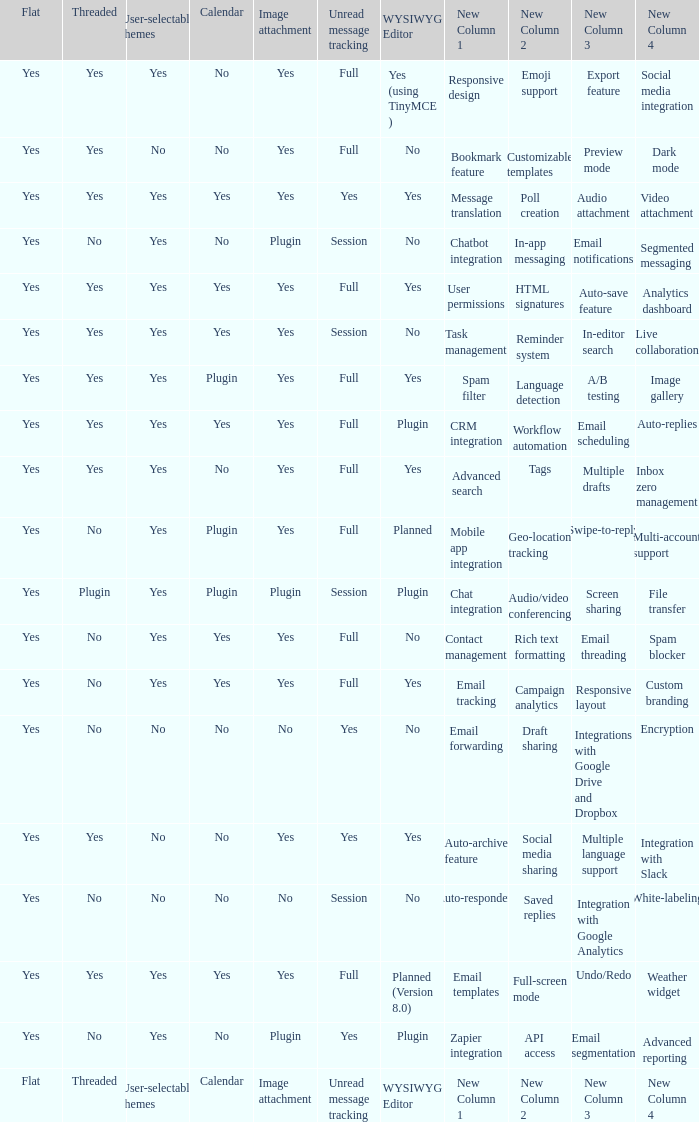Which Calendar has a WYSIWYG Editor of no, and an Unread message tracking of session, and an Image attachment of no? No. Could you help me parse every detail presented in this table? {'header': ['Flat', 'Threaded', 'User-selectable themes', 'Calendar', 'Image attachment', 'Unread message tracking', 'WYSIWYG Editor', 'New Column 1', 'New Column 2', 'New Column 3', 'New Column 4'], 'rows': [['Yes', 'Yes', 'Yes', 'No', 'Yes', 'Full', 'Yes (using TinyMCE )', 'Responsive design', 'Emoji support', 'Export feature', 'Social media integration'], ['Yes', 'Yes', 'No', 'No', 'Yes', 'Full', 'No', 'Bookmark feature', 'Customizable templates', 'Preview mode', 'Dark mode '], ['Yes', 'Yes', 'Yes', 'Yes', 'Yes', 'Yes', 'Yes', 'Message translation', 'Poll creation', 'Audio attachment', 'Video attachment '], ['Yes', 'No', 'Yes', 'No', 'Plugin', 'Session', 'No', 'Chatbot integration', 'In-app messaging', 'Email notifications', 'Segmented messaging'], ['Yes', 'Yes', 'Yes', 'Yes', 'Yes', 'Full', 'Yes', 'User permissions', 'HTML signatures', 'Auto-save feature', 'Analytics dashboard'], ['Yes', 'Yes', 'Yes', 'Yes', 'Yes', 'Session', 'No', 'Task management', 'Reminder system', 'In-editor search', 'Live collaboration'], ['Yes', 'Yes', 'Yes', 'Plugin', 'Yes', 'Full', 'Yes', 'Spam filter', 'Language detection', 'A/B testing', 'Image gallery'], ['Yes', 'Yes', 'Yes', 'Yes', 'Yes', 'Full', 'Plugin', 'CRM integration', 'Workflow automation', 'Email scheduling', 'Auto-replies'], ['Yes', 'Yes', 'Yes', 'No', 'Yes', 'Full', 'Yes', 'Advanced search', 'Tags', 'Multiple drafts', 'Inbox zero management'], ['Yes', 'No', 'Yes', 'Plugin', 'Yes', 'Full', 'Planned', 'Mobile app integration', 'Geo-location tracking', 'Swipe-to-reply', 'Multi-account support '], ['Yes', 'Plugin', 'Yes', 'Plugin', 'Plugin', 'Session', 'Plugin', 'Chat integration', 'Audio/video conferencing', 'Screen sharing', 'File transfer'], ['Yes', 'No', 'Yes', 'Yes', 'Yes', 'Full', 'No', 'Contact management', 'Rich text formatting', 'Email threading', 'Spam blocker'], ['Yes', 'No', 'Yes', 'Yes', 'Yes', 'Full', 'Yes', 'Email tracking', 'Campaign analytics', 'Responsive layout', 'Custom branding'], ['Yes', 'No', 'No', 'No', 'No', 'Yes', 'No', 'Email forwarding', 'Draft sharing', 'Integrations with Google Drive and Dropbox', 'Encryption'], ['Yes', 'Yes', 'No', 'No', 'Yes', 'Yes', 'Yes', 'Auto-archive feature', 'Social media sharing', 'Multiple language support', 'Integration with Slack'], ['Yes', 'No', 'No', 'No', 'No', 'Session', 'No', 'Auto-responders', 'Saved replies', 'Integration with Google Analytics', 'White-labeling'], ['Yes', 'Yes', 'Yes', 'Yes', 'Yes', 'Full', 'Planned (Version 8.0)', 'Email templates', 'Full-screen mode', 'Undo/Redo', 'Weather widget'], ['Yes', 'No', 'Yes', 'No', 'Plugin', 'Yes', 'Plugin', 'Zapier integration', 'API access', 'Email segmentation', 'Advanced reporting '], ['Flat', 'Threaded', 'User-selectable themes', 'Calendar', 'Image attachment', 'Unread message tracking', 'WYSIWYG Editor', 'New Column 1', 'New Column 2', 'New Column 3', 'New Column 4']]} 